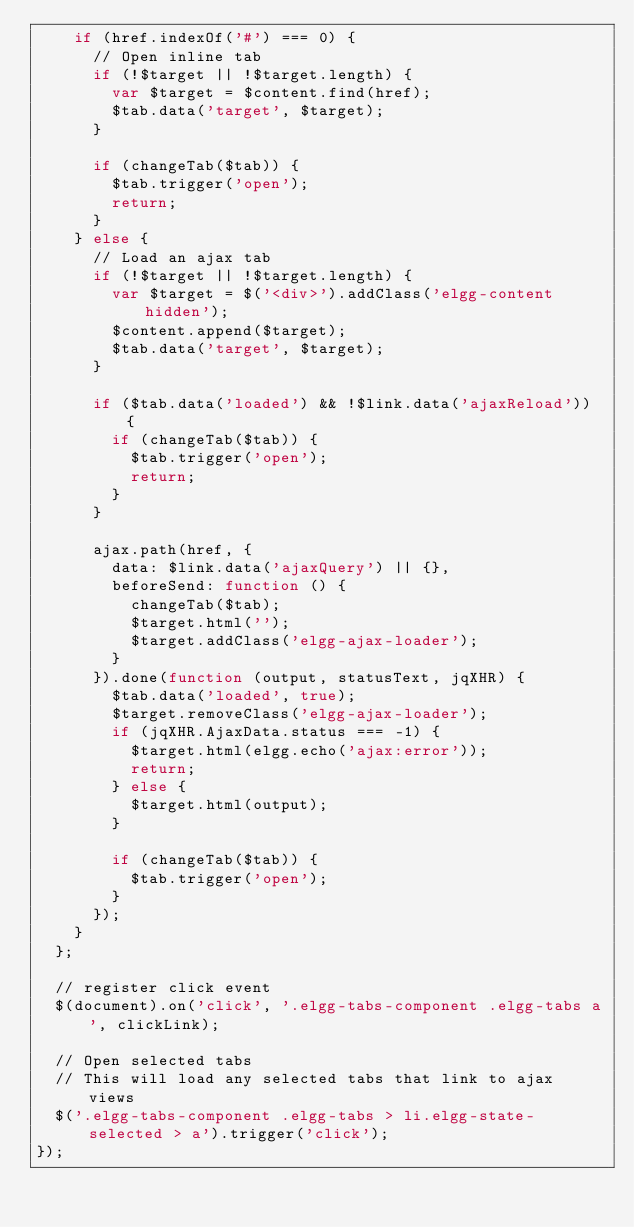Convert code to text. <code><loc_0><loc_0><loc_500><loc_500><_JavaScript_>		if (href.indexOf('#') === 0) {
			// Open inline tab
			if (!$target || !$target.length) {
				var $target = $content.find(href);
				$tab.data('target', $target);
			}

			if (changeTab($tab)) {
				$tab.trigger('open');
				return;
			}
		} else {
			// Load an ajax tab
			if (!$target || !$target.length) {
				var $target = $('<div>').addClass('elgg-content hidden');
				$content.append($target);
				$tab.data('target', $target);
			}

			if ($tab.data('loaded') && !$link.data('ajaxReload')) {
				if (changeTab($tab)) {
					$tab.trigger('open');
					return;
				}
			}
			
			ajax.path(href, {
				data: $link.data('ajaxQuery') || {},
				beforeSend: function () {
					changeTab($tab);
					$target.html('');
					$target.addClass('elgg-ajax-loader');
				}
			}).done(function (output, statusText, jqXHR) {
				$tab.data('loaded', true);
				$target.removeClass('elgg-ajax-loader');
				if (jqXHR.AjaxData.status === -1) {
					$target.html(elgg.echo('ajax:error'));
					return;
				} else {
					$target.html(output);
				}

				if (changeTab($tab)) {
					$tab.trigger('open');
				}
			});
		}
	};

	// register click event
	$(document).on('click', '.elgg-tabs-component .elgg-tabs a', clickLink);

	// Open selected tabs
	// This will load any selected tabs that link to ajax views
	$('.elgg-tabs-component .elgg-tabs > li.elgg-state-selected > a').trigger('click');
});


</code> 